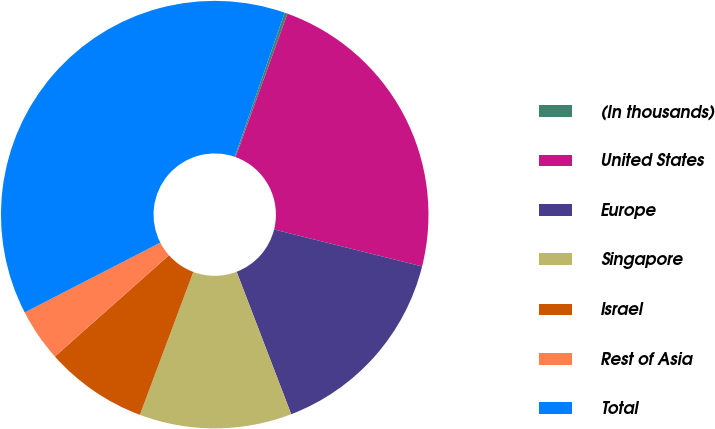<chart> <loc_0><loc_0><loc_500><loc_500><pie_chart><fcel>(In thousands)<fcel>United States<fcel>Europe<fcel>Singapore<fcel>Israel<fcel>Rest of Asia<fcel>Total<nl><fcel>0.22%<fcel>23.37%<fcel>15.28%<fcel>11.52%<fcel>7.75%<fcel>3.99%<fcel>37.87%<nl></chart> 